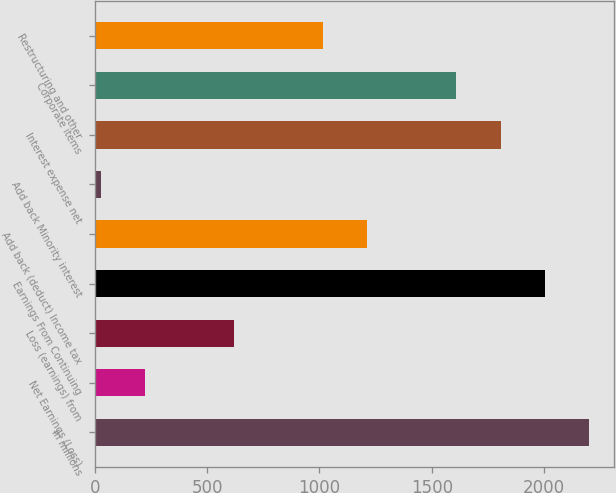Convert chart to OTSL. <chart><loc_0><loc_0><loc_500><loc_500><bar_chart><fcel>In millions<fcel>Net Earnings (Loss)<fcel>Loss (earnings) from<fcel>Earnings From Continuing<fcel>Add back (deduct) Income tax<fcel>Add back Minority interest<fcel>Interest expense net<fcel>Corporate items<fcel>Restructuring and other<nl><fcel>2201.8<fcel>223.8<fcel>619.4<fcel>2004<fcel>1212.8<fcel>26<fcel>1806.2<fcel>1608.4<fcel>1015<nl></chart> 